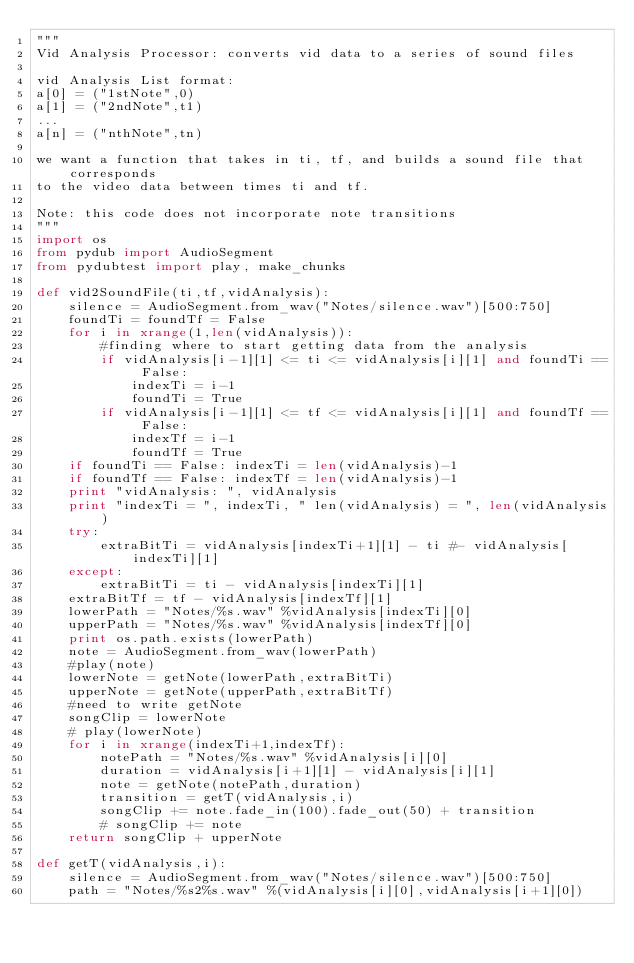Convert code to text. <code><loc_0><loc_0><loc_500><loc_500><_Python_>"""
Vid Analysis Processor: converts vid data to a series of sound files

vid Analysis List format:
a[0] = ("1stNote",0)
a[1] = ("2ndNote",t1)
...
a[n] = ("nthNote",tn)

we want a function that takes in ti, tf, and builds a sound file that corresponds
to the video data between times ti and tf.

Note: this code does not incorporate note transitions
"""
import os
from pydub import AudioSegment
from pydubtest import play, make_chunks

def vid2SoundFile(ti,tf,vidAnalysis):
	silence = AudioSegment.from_wav("Notes/silence.wav")[500:750]
	foundTi = foundTf = False
	for i in xrange(1,len(vidAnalysis)):
		#finding where to start getting data from the analysis
		if vidAnalysis[i-1][1] <= ti <= vidAnalysis[i][1] and foundTi == False:
			indexTi = i-1
			foundTi = True
		if vidAnalysis[i-1][1] <= tf <= vidAnalysis[i][1] and foundTf == False:
			indexTf = i-1
			foundTf = True
	if foundTi == False: indexTi = len(vidAnalysis)-1
	if foundTf == False: indexTf = len(vidAnalysis)-1
	print "vidAnalysis: ", vidAnalysis
	print "indexTi = ", indexTi, " len(vidAnalysis) = ", len(vidAnalysis)
	try:
		extraBitTi = vidAnalysis[indexTi+1][1] - ti #- vidAnalysis[indexTi][1]
	except:
		extraBitTi = ti - vidAnalysis[indexTi][1]
	extraBitTf = tf - vidAnalysis[indexTf][1]
	lowerPath = "Notes/%s.wav" %vidAnalysis[indexTi][0]
	upperPath = "Notes/%s.wav" %vidAnalysis[indexTf][0]
	print os.path.exists(lowerPath)
	note = AudioSegment.from_wav(lowerPath)
	#play(note)
	lowerNote = getNote(lowerPath,extraBitTi)
	upperNote = getNote(upperPath,extraBitTf)
	#need to write getNote
	songClip = lowerNote
	# play(lowerNote)
	for i in xrange(indexTi+1,indexTf):
		notePath = "Notes/%s.wav" %vidAnalysis[i][0]
		duration = vidAnalysis[i+1][1] - vidAnalysis[i][1]
		note = getNote(notePath,duration)
		transition = getT(vidAnalysis,i)
		songClip += note.fade_in(100).fade_out(50) + transition
		# songClip += note
	return songClip + upperNote

def getT(vidAnalysis,i):
	silence = AudioSegment.from_wav("Notes/silence.wav")[500:750]
	path = "Notes/%s2%s.wav" %(vidAnalysis[i][0],vidAnalysis[i+1][0])</code> 